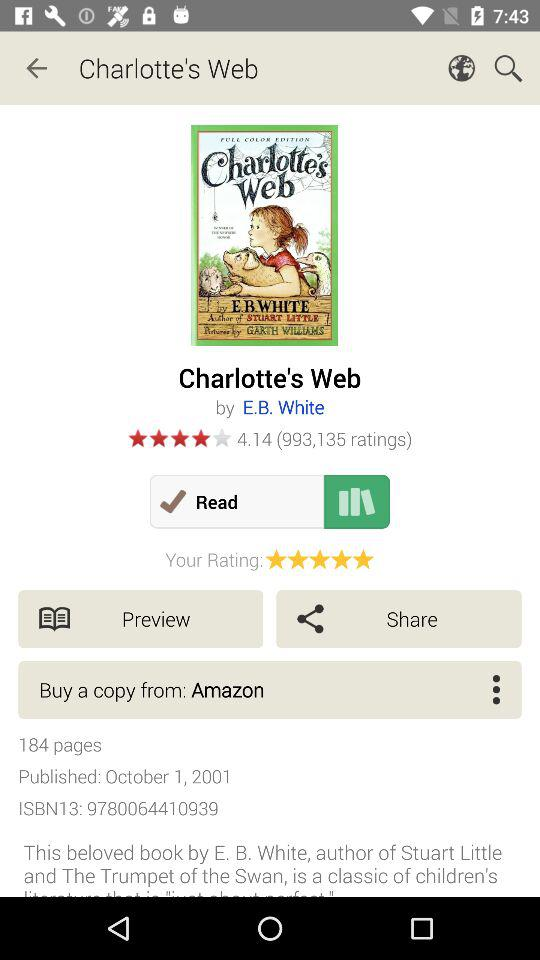What is the book's ISBN13 number? The book's ISBN13 number is 9780064410939. 